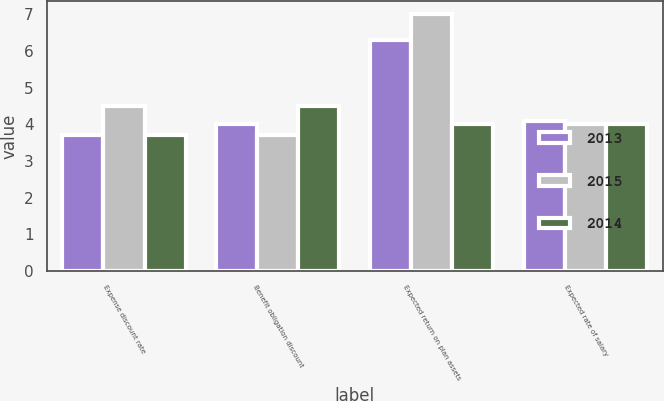<chart> <loc_0><loc_0><loc_500><loc_500><stacked_bar_chart><ecel><fcel>Expense discount rate<fcel>Benefit obligation discount<fcel>Expected return on plan assets<fcel>Expected rate of salary<nl><fcel>2013<fcel>3.7<fcel>4<fcel>6.3<fcel>4.1<nl><fcel>2015<fcel>4.5<fcel>3.7<fcel>7<fcel>4<nl><fcel>2014<fcel>3.7<fcel>4.5<fcel>4<fcel>4<nl></chart> 